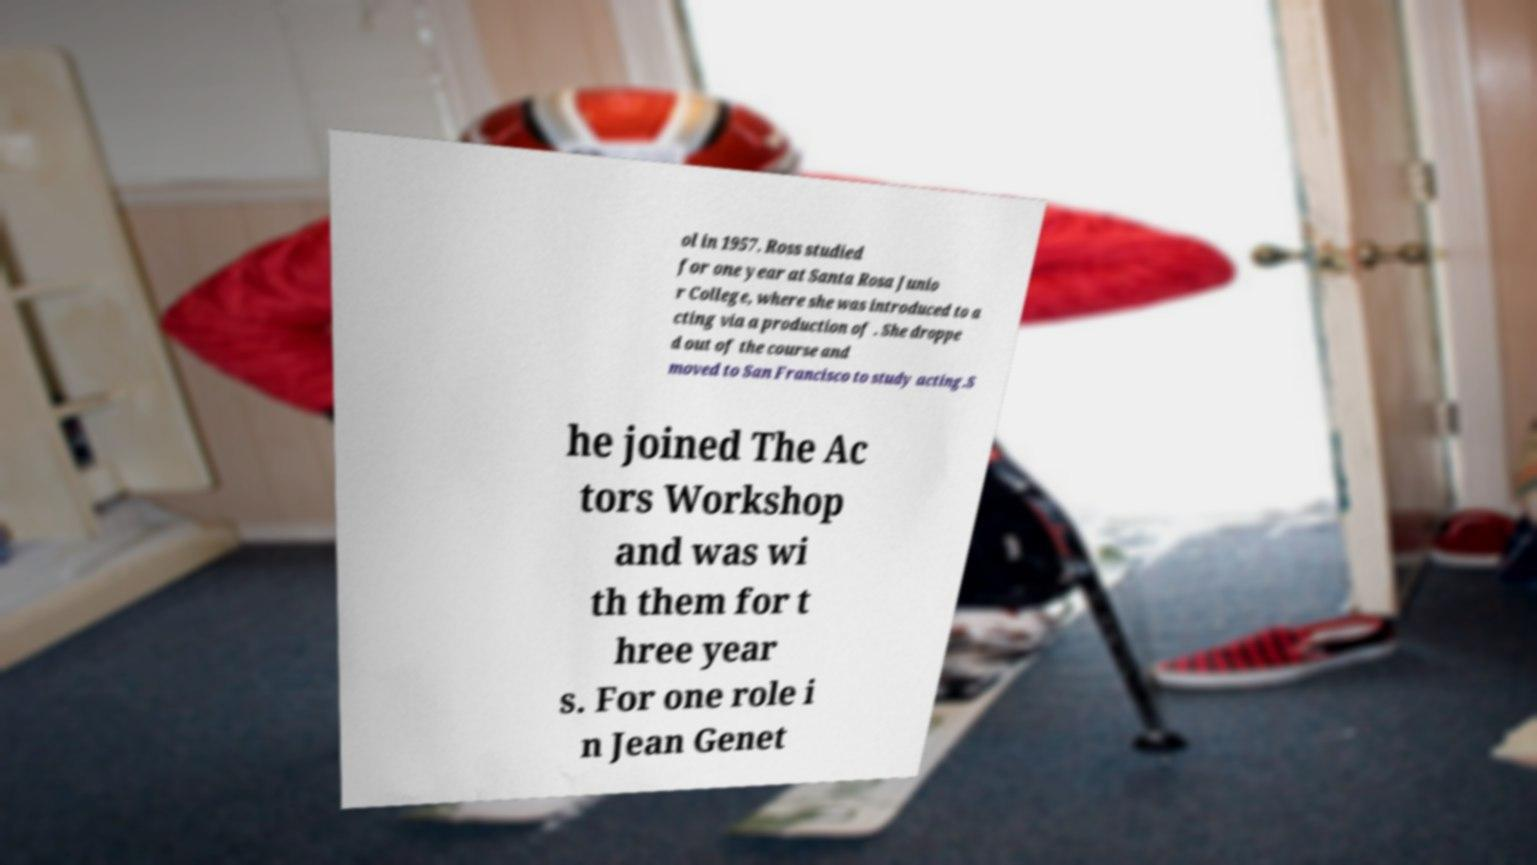For documentation purposes, I need the text within this image transcribed. Could you provide that? ol in 1957. Ross studied for one year at Santa Rosa Junio r College, where she was introduced to a cting via a production of . She droppe d out of the course and moved to San Francisco to study acting.S he joined The Ac tors Workshop and was wi th them for t hree year s. For one role i n Jean Genet 